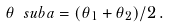<formula> <loc_0><loc_0><loc_500><loc_500>\theta \ s u b { a } = ( \theta _ { 1 } + \theta _ { 2 } ) / 2 \, .</formula> 